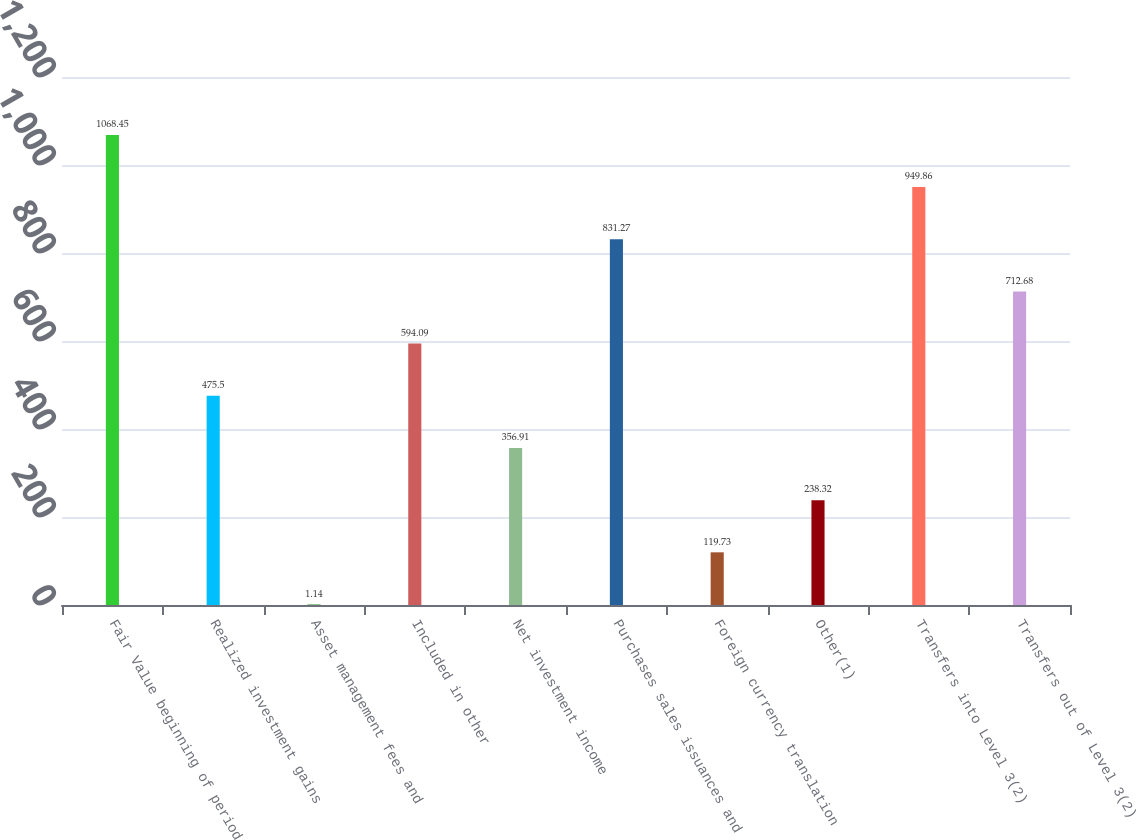Convert chart. <chart><loc_0><loc_0><loc_500><loc_500><bar_chart><fcel>Fair Value beginning of period<fcel>Realized investment gains<fcel>Asset management fees and<fcel>Included in other<fcel>Net investment income<fcel>Purchases sales issuances and<fcel>Foreign currency translation<fcel>Other(1)<fcel>Transfers into Level 3(2)<fcel>Transfers out of Level 3(2)<nl><fcel>1068.45<fcel>475.5<fcel>1.14<fcel>594.09<fcel>356.91<fcel>831.27<fcel>119.73<fcel>238.32<fcel>949.86<fcel>712.68<nl></chart> 